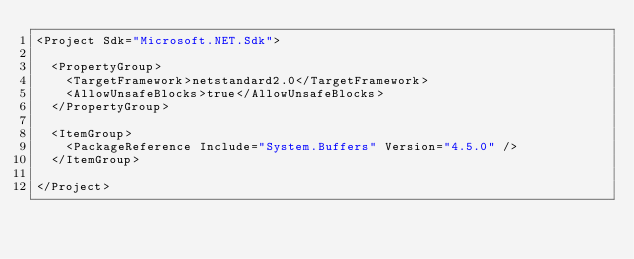Convert code to text. <code><loc_0><loc_0><loc_500><loc_500><_XML_><Project Sdk="Microsoft.NET.Sdk">

  <PropertyGroup>
    <TargetFramework>netstandard2.0</TargetFramework>
    <AllowUnsafeBlocks>true</AllowUnsafeBlocks>
  </PropertyGroup>

  <ItemGroup>
    <PackageReference Include="System.Buffers" Version="4.5.0" />
  </ItemGroup>

</Project>
</code> 